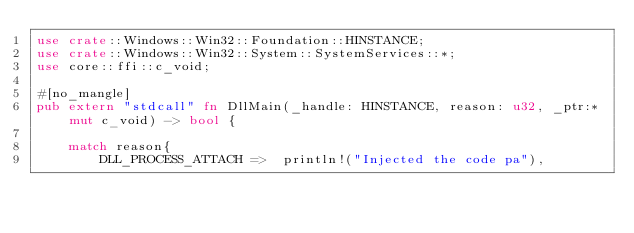Convert code to text. <code><loc_0><loc_0><loc_500><loc_500><_Rust_>use crate::Windows::Win32::Foundation::HINSTANCE;
use crate::Windows::Win32::System::SystemServices::*;
use core::ffi::c_void;

#[no_mangle]
pub extern "stdcall" fn DllMain(_handle: HINSTANCE, reason: u32, _ptr:*mut c_void) -> bool {

    match reason{
        DLL_PROCESS_ATTACH =>  println!("Injected the code pa"),</code> 